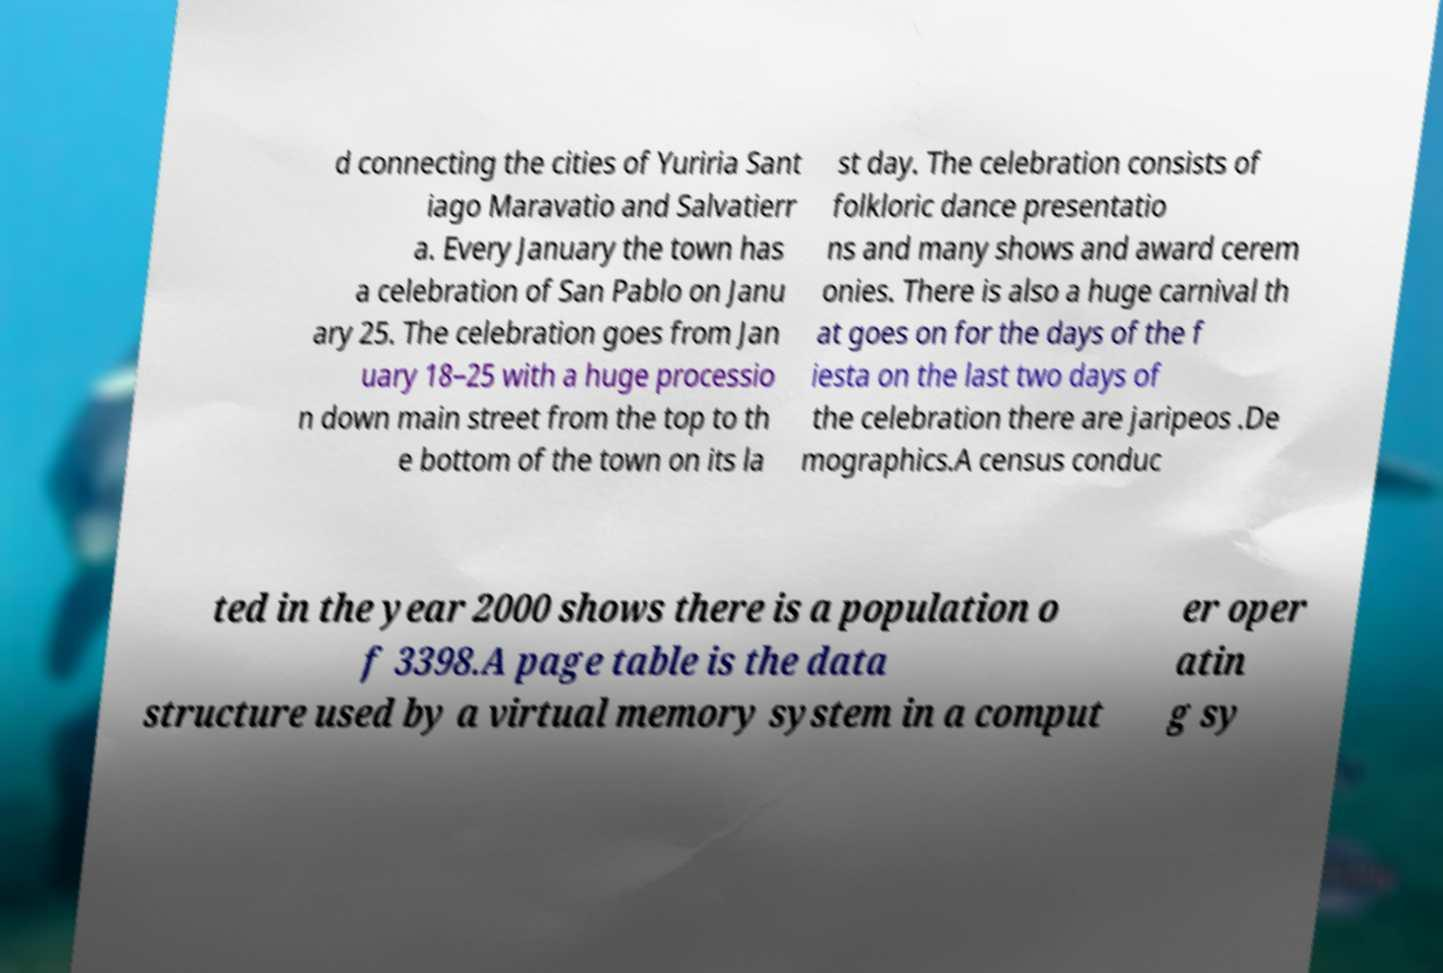Please identify and transcribe the text found in this image. d connecting the cities of Yuriria Sant iago Maravatio and Salvatierr a. Every January the town has a celebration of San Pablo on Janu ary 25. The celebration goes from Jan uary 18–25 with a huge processio n down main street from the top to th e bottom of the town on its la st day. The celebration consists of folkloric dance presentatio ns and many shows and award cerem onies. There is also a huge carnival th at goes on for the days of the f iesta on the last two days of the celebration there are jaripeos .De mographics.A census conduc ted in the year 2000 shows there is a population o f 3398.A page table is the data structure used by a virtual memory system in a comput er oper atin g sy 